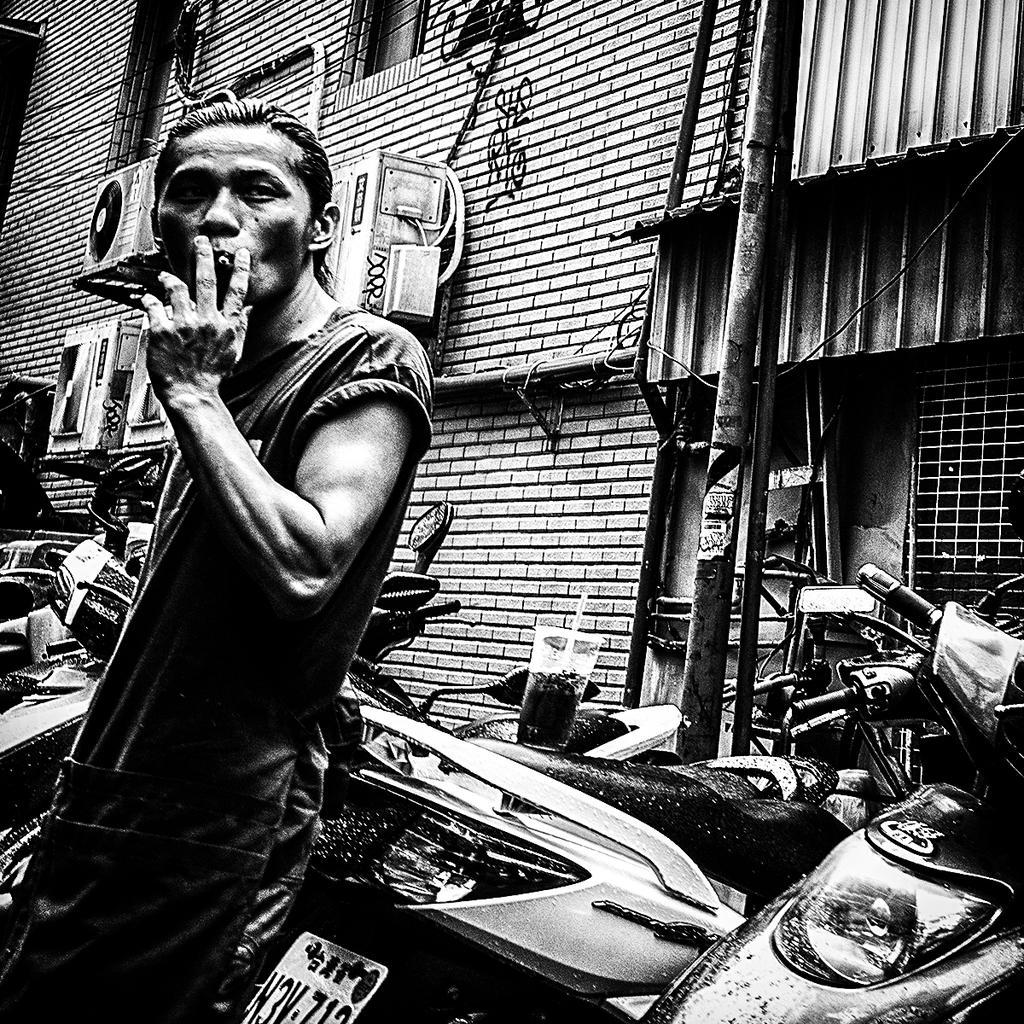Could you give a brief overview of what you see in this image? In this picture I can see there is a man standing here and he is smoking and there is a glass on the motorcycles on to right and there is a building in the backdrop and there is a pole on to right. 